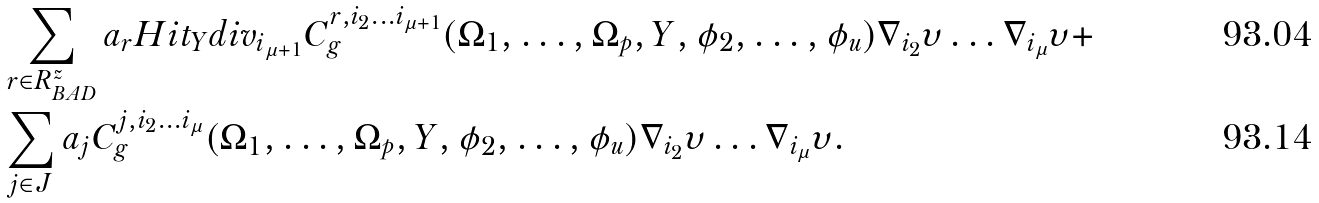<formula> <loc_0><loc_0><loc_500><loc_500>& \sum _ { r \in R ^ { z } _ { B A D } } a _ { r } H i t _ { Y } d i v _ { i _ { \mu + 1 } } C ^ { r , i _ { 2 } \dots i _ { \mu + 1 } } _ { g } ( \Omega _ { 1 } , \dots , \Omega _ { p } , Y , \phi _ { 2 } , \dots , \phi _ { u } ) \nabla _ { i _ { 2 } } \upsilon \dots \nabla _ { i _ { \mu } } \upsilon + \\ & \sum _ { j \in J } a _ { j } C ^ { j , i _ { 2 } \dots i _ { \mu } } _ { g } ( \Omega _ { 1 } , \dots , \Omega _ { p } , Y , \phi _ { 2 } , \dots , \phi _ { u } ) \nabla _ { i _ { 2 } } \upsilon \dots \nabla _ { i _ { \mu } } \upsilon .</formula> 